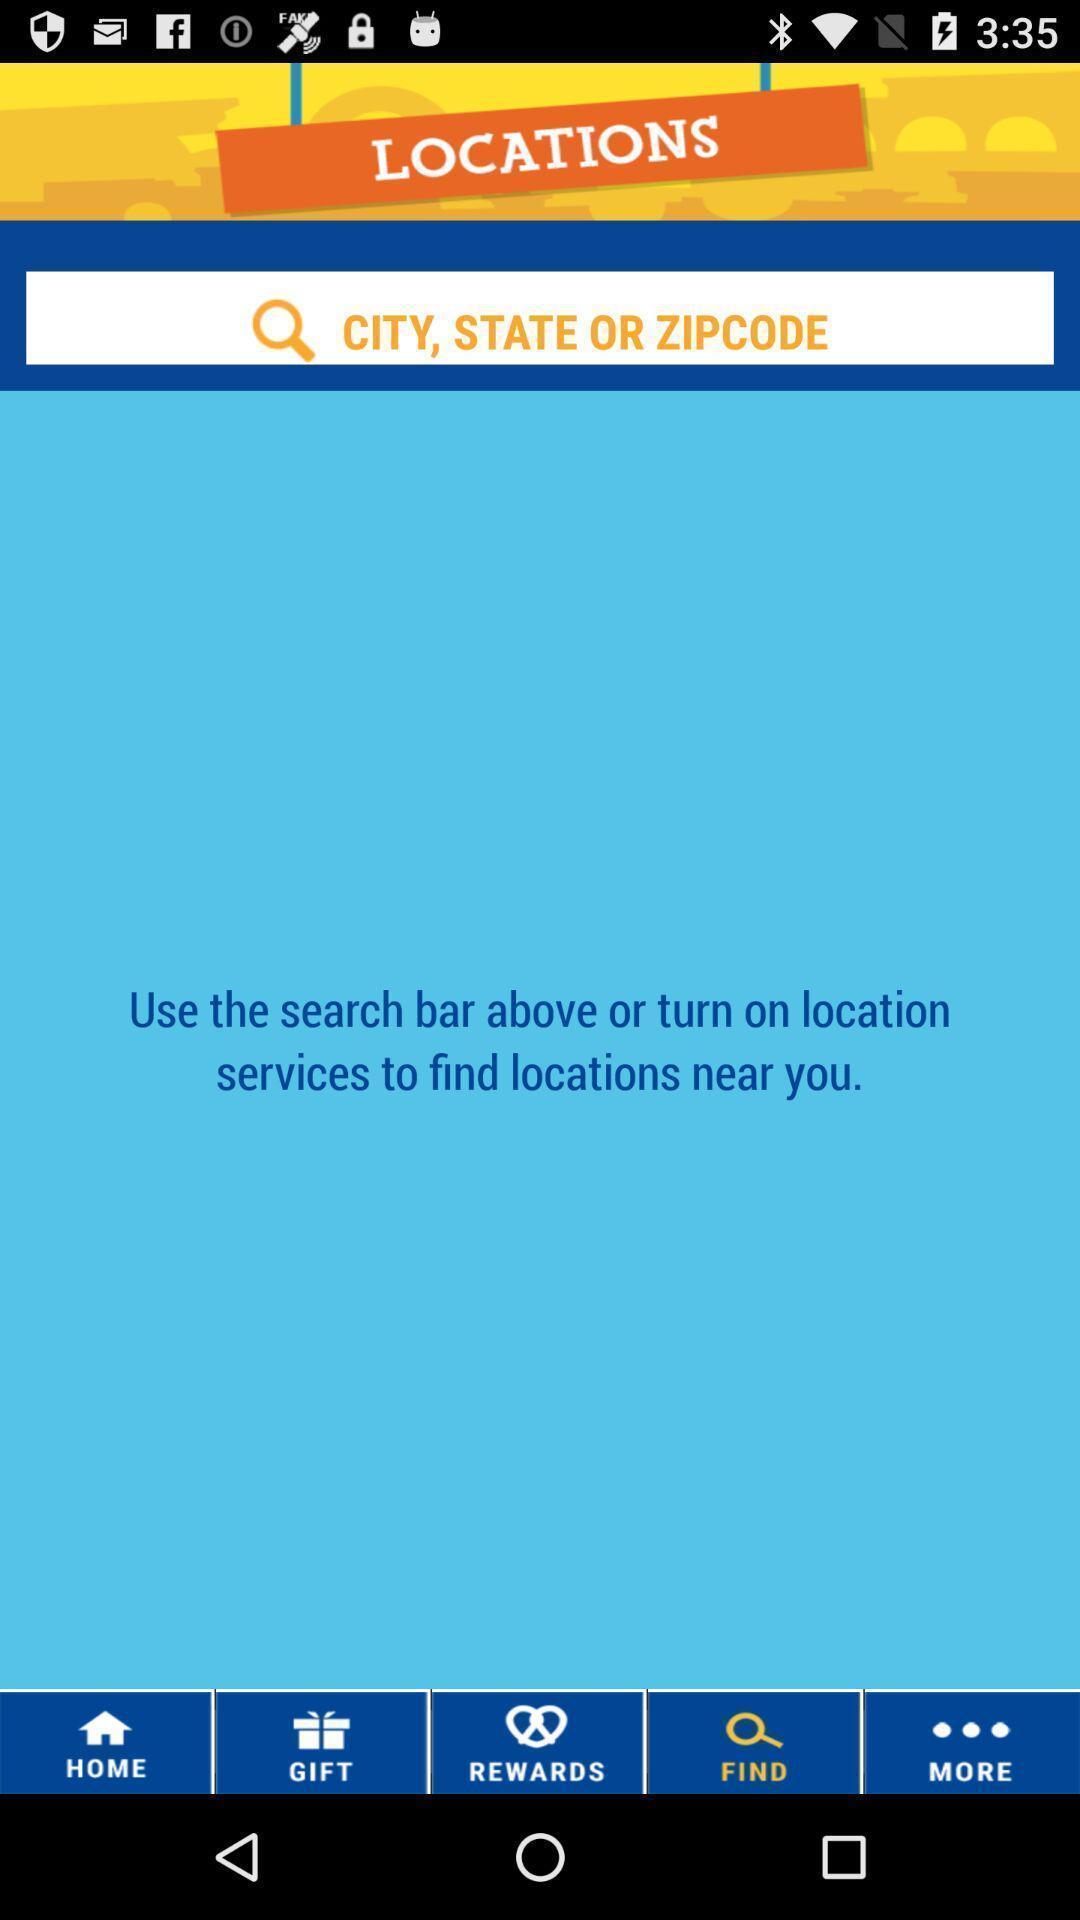Give me a narrative description of this picture. Search page to find location. 